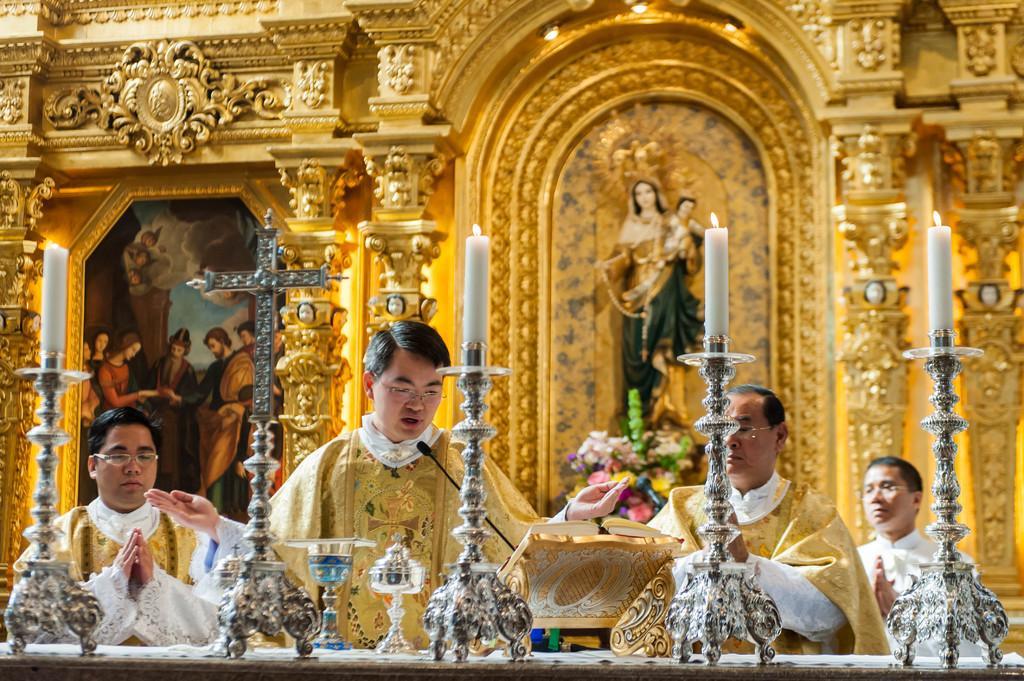Please provide a concise description of this image. Here we can see four persons and there are candles, flower bouquet, and a sculpture. In the background we can see a frame and design wall. 